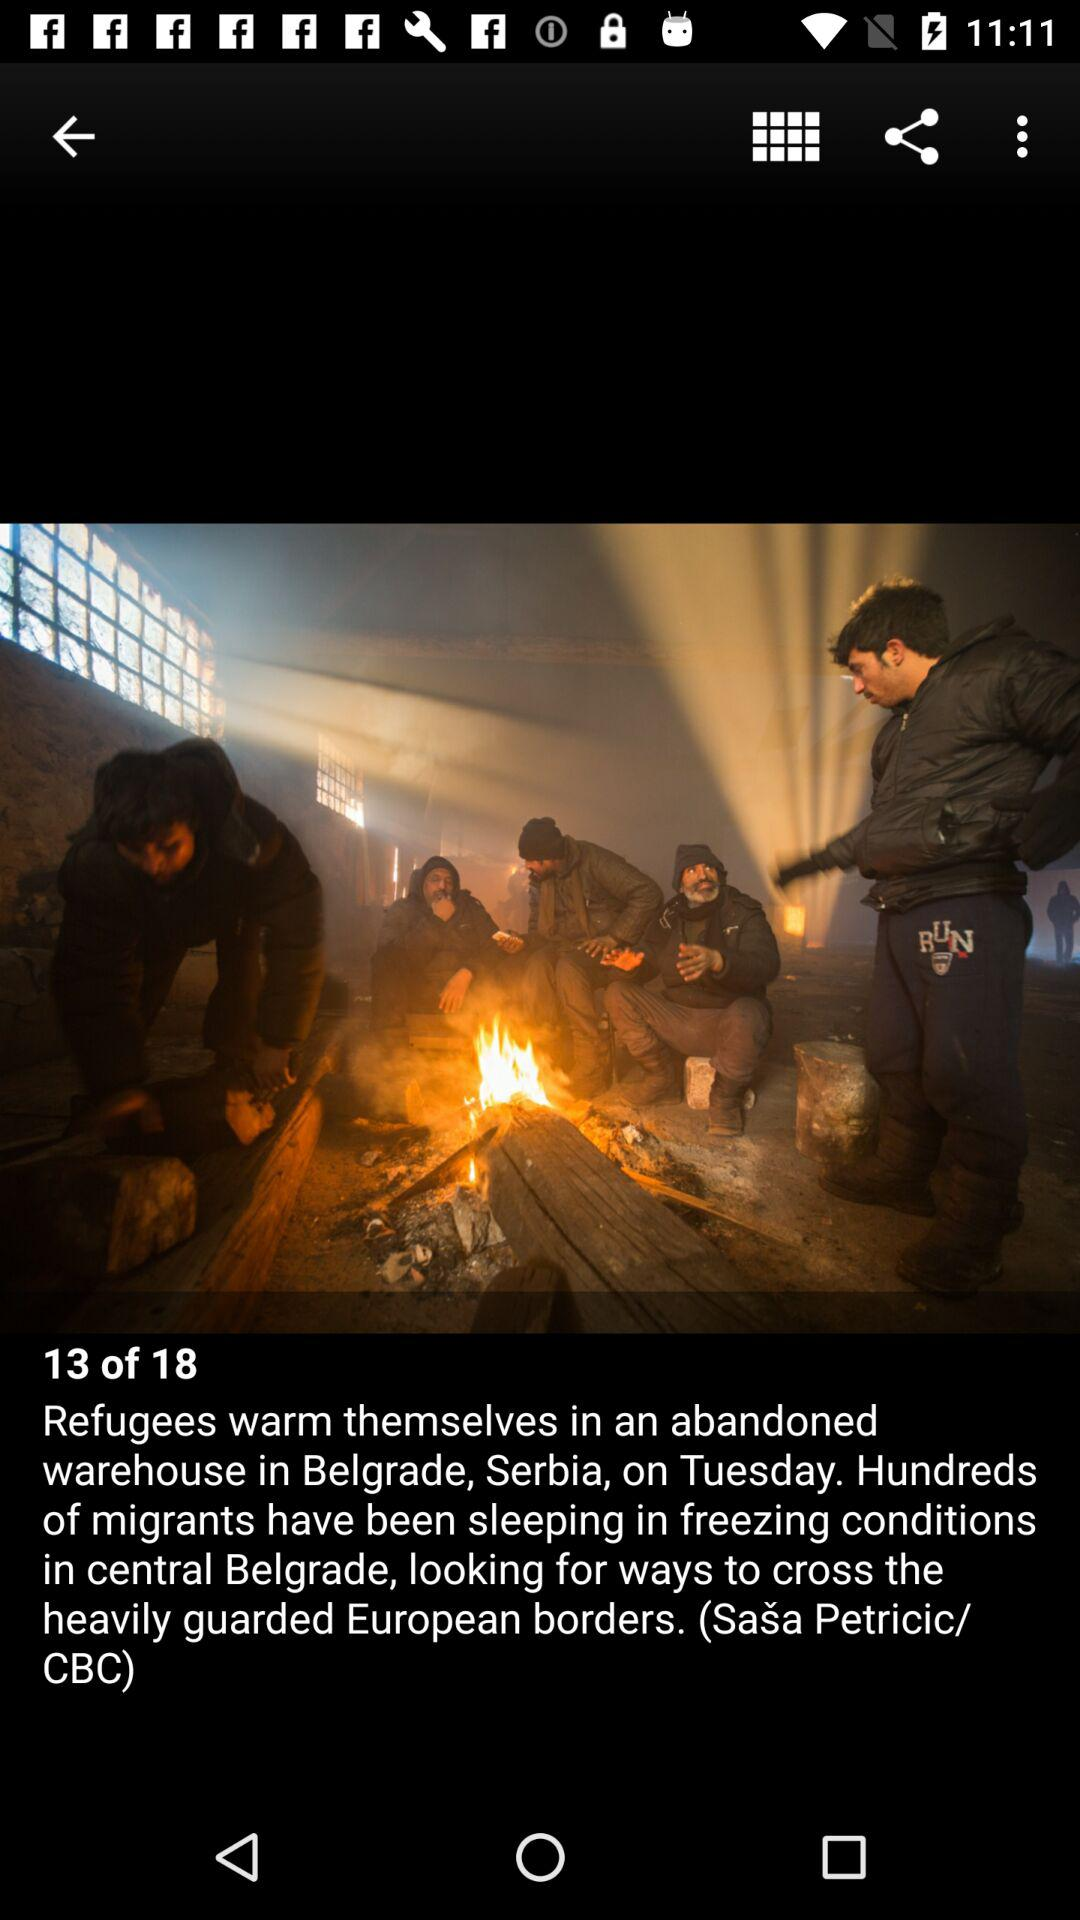Which image number are we currently on? You are currently on image number 13. 